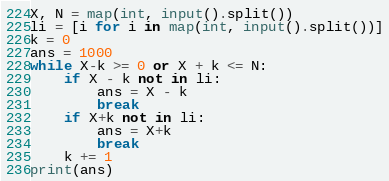Convert code to text. <code><loc_0><loc_0><loc_500><loc_500><_Python_>X, N = map(int, input().split())
li = [i for i in map(int, input().split())]
k = 0
ans = 1000
while X-k >= 0 or X + k <= N:
    if X - k not in li:
        ans = X - k
        break
    if X+k not in li:
        ans = X+k
        break
    k += 1
print(ans)</code> 